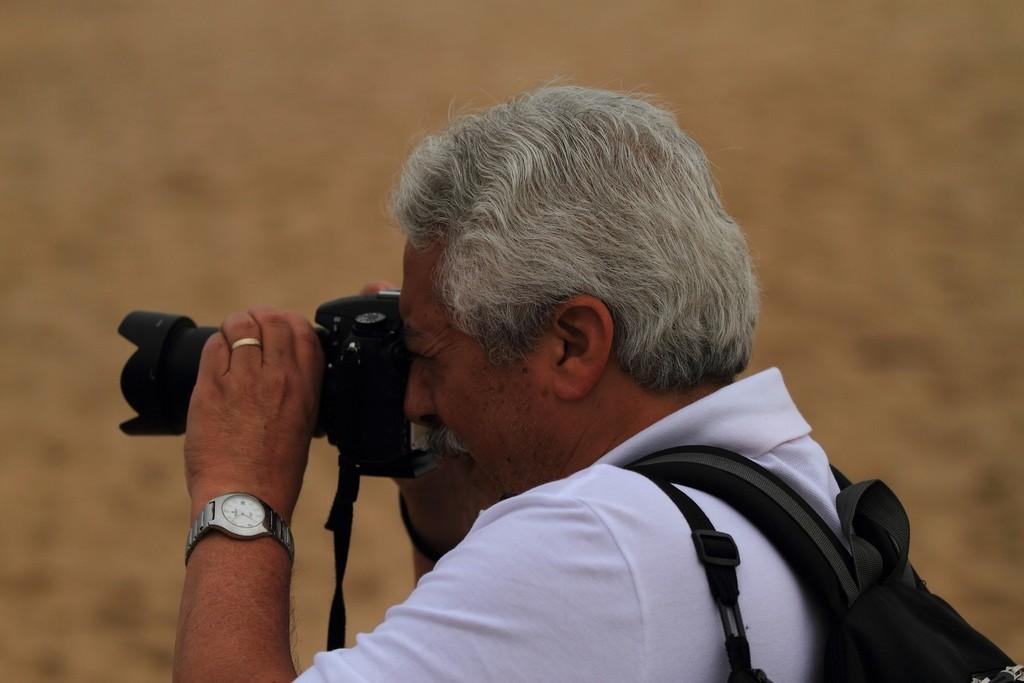Who is the main subject in the image? There is a man in the image. What is the man holding in his hands? The man is holding a camera in his hands. What is the man doing with the camera? The man is clicking pictures with the camera. What type of tomatoes can be seen growing in the background of the image? There are no tomatoes present in the image; it features a man holding a camera and clicking pictures. 